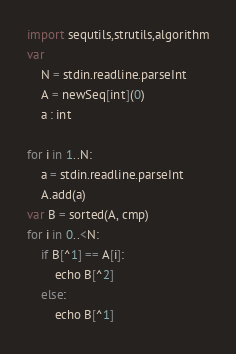Convert code to text. <code><loc_0><loc_0><loc_500><loc_500><_Nim_>import sequtils,strutils,algorithm
var
    N = stdin.readline.parseInt
    A = newSeq[int](0)
    a : int

for i in 1..N:
    a = stdin.readline.parseInt
    A.add(a)
var B = sorted(A, cmp)
for i in 0..<N:
    if B[^1] == A[i]:
        echo B[^2]
    else:
        echo B[^1]
</code> 